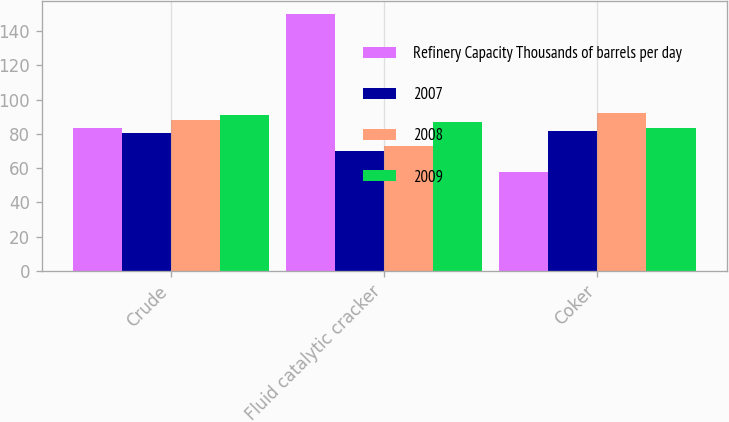<chart> <loc_0><loc_0><loc_500><loc_500><stacked_bar_chart><ecel><fcel>Crude<fcel>Fluid catalytic cracker<fcel>Coker<nl><fcel>Refinery Capacity Thousands of barrels per day<fcel>83.4<fcel>150<fcel>58<nl><fcel>2007<fcel>80.3<fcel>70.2<fcel>81.6<nl><fcel>2008<fcel>88.2<fcel>72.7<fcel>92.4<nl><fcel>2009<fcel>90.8<fcel>87.1<fcel>83.4<nl></chart> 